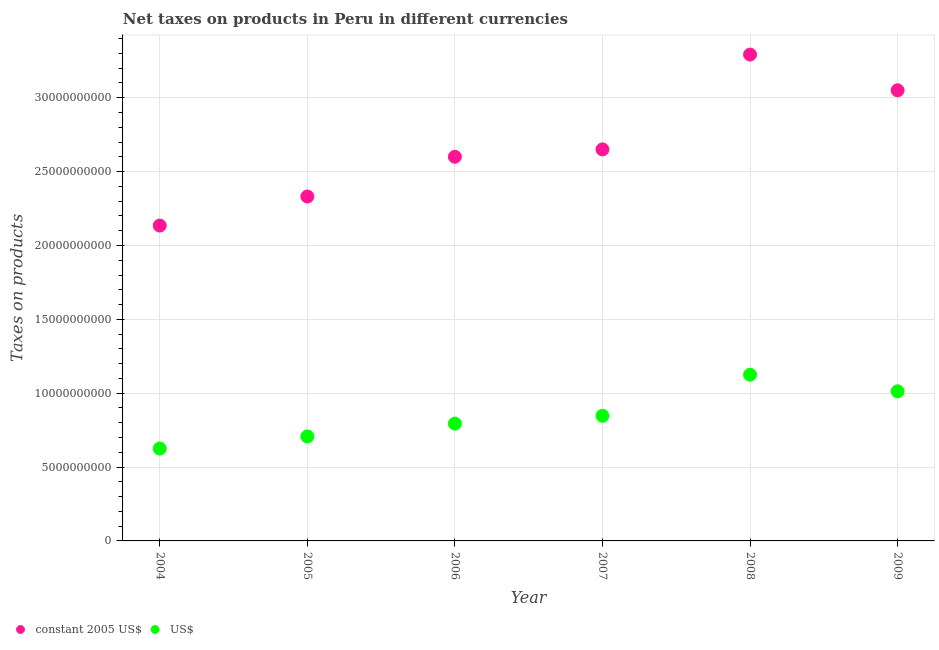How many different coloured dotlines are there?
Give a very brief answer. 2. Is the number of dotlines equal to the number of legend labels?
Keep it short and to the point. Yes. What is the net taxes in constant 2005 us$ in 2006?
Offer a very short reply. 2.60e+1. Across all years, what is the maximum net taxes in constant 2005 us$?
Your answer should be compact. 3.29e+1. Across all years, what is the minimum net taxes in us$?
Make the answer very short. 6.25e+09. In which year was the net taxes in constant 2005 us$ minimum?
Give a very brief answer. 2004. What is the total net taxes in us$ in the graph?
Make the answer very short. 5.11e+1. What is the difference between the net taxes in us$ in 2005 and that in 2007?
Your answer should be compact. -1.40e+09. What is the difference between the net taxes in us$ in 2004 and the net taxes in constant 2005 us$ in 2005?
Keep it short and to the point. -1.71e+1. What is the average net taxes in us$ per year?
Make the answer very short. 8.52e+09. In the year 2008, what is the difference between the net taxes in constant 2005 us$ and net taxes in us$?
Make the answer very short. 2.17e+1. What is the ratio of the net taxes in us$ in 2007 to that in 2009?
Provide a short and direct response. 0.84. Is the net taxes in us$ in 2008 less than that in 2009?
Provide a short and direct response. No. What is the difference between the highest and the second highest net taxes in constant 2005 us$?
Give a very brief answer. 2.42e+09. What is the difference between the highest and the lowest net taxes in constant 2005 us$?
Keep it short and to the point. 1.16e+1. Does the net taxes in us$ monotonically increase over the years?
Offer a very short reply. No. Is the net taxes in us$ strictly greater than the net taxes in constant 2005 us$ over the years?
Give a very brief answer. No. How many years are there in the graph?
Keep it short and to the point. 6. What is the difference between two consecutive major ticks on the Y-axis?
Offer a terse response. 5.00e+09. Are the values on the major ticks of Y-axis written in scientific E-notation?
Your answer should be very brief. No. How many legend labels are there?
Make the answer very short. 2. What is the title of the graph?
Your answer should be very brief. Net taxes on products in Peru in different currencies. Does "Frequency of shipment arrival" appear as one of the legend labels in the graph?
Make the answer very short. No. What is the label or title of the Y-axis?
Keep it short and to the point. Taxes on products. What is the Taxes on products of constant 2005 US$ in 2004?
Give a very brief answer. 2.13e+1. What is the Taxes on products in US$ in 2004?
Offer a terse response. 6.25e+09. What is the Taxes on products in constant 2005 US$ in 2005?
Ensure brevity in your answer.  2.33e+1. What is the Taxes on products in US$ in 2005?
Offer a very short reply. 7.07e+09. What is the Taxes on products in constant 2005 US$ in 2006?
Keep it short and to the point. 2.60e+1. What is the Taxes on products in US$ in 2006?
Your answer should be compact. 7.94e+09. What is the Taxes on products of constant 2005 US$ in 2007?
Keep it short and to the point. 2.65e+1. What is the Taxes on products in US$ in 2007?
Provide a succinct answer. 8.47e+09. What is the Taxes on products of constant 2005 US$ in 2008?
Keep it short and to the point. 3.29e+1. What is the Taxes on products of US$ in 2008?
Make the answer very short. 1.13e+1. What is the Taxes on products in constant 2005 US$ in 2009?
Your answer should be very brief. 3.05e+1. What is the Taxes on products of US$ in 2009?
Ensure brevity in your answer.  1.01e+1. Across all years, what is the maximum Taxes on products of constant 2005 US$?
Your answer should be very brief. 3.29e+1. Across all years, what is the maximum Taxes on products of US$?
Give a very brief answer. 1.13e+1. Across all years, what is the minimum Taxes on products of constant 2005 US$?
Keep it short and to the point. 2.13e+1. Across all years, what is the minimum Taxes on products of US$?
Provide a short and direct response. 6.25e+09. What is the total Taxes on products of constant 2005 US$ in the graph?
Provide a short and direct response. 1.61e+11. What is the total Taxes on products in US$ in the graph?
Your response must be concise. 5.11e+1. What is the difference between the Taxes on products in constant 2005 US$ in 2004 and that in 2005?
Provide a short and direct response. -1.97e+09. What is the difference between the Taxes on products of US$ in 2004 and that in 2005?
Provide a short and direct response. -8.19e+08. What is the difference between the Taxes on products of constant 2005 US$ in 2004 and that in 2006?
Give a very brief answer. -4.66e+09. What is the difference between the Taxes on products of US$ in 2004 and that in 2006?
Ensure brevity in your answer.  -1.69e+09. What is the difference between the Taxes on products of constant 2005 US$ in 2004 and that in 2007?
Your answer should be very brief. -5.16e+09. What is the difference between the Taxes on products of US$ in 2004 and that in 2007?
Keep it short and to the point. -2.22e+09. What is the difference between the Taxes on products of constant 2005 US$ in 2004 and that in 2008?
Your answer should be compact. -1.16e+1. What is the difference between the Taxes on products of US$ in 2004 and that in 2008?
Make the answer very short. -5.00e+09. What is the difference between the Taxes on products of constant 2005 US$ in 2004 and that in 2009?
Offer a terse response. -9.16e+09. What is the difference between the Taxes on products of US$ in 2004 and that in 2009?
Your answer should be compact. -3.87e+09. What is the difference between the Taxes on products in constant 2005 US$ in 2005 and that in 2006?
Make the answer very short. -2.69e+09. What is the difference between the Taxes on products of US$ in 2005 and that in 2006?
Ensure brevity in your answer.  -8.69e+08. What is the difference between the Taxes on products in constant 2005 US$ in 2005 and that in 2007?
Your answer should be compact. -3.19e+09. What is the difference between the Taxes on products in US$ in 2005 and that in 2007?
Your answer should be compact. -1.40e+09. What is the difference between the Taxes on products of constant 2005 US$ in 2005 and that in 2008?
Offer a very short reply. -9.61e+09. What is the difference between the Taxes on products in US$ in 2005 and that in 2008?
Provide a succinct answer. -4.18e+09. What is the difference between the Taxes on products of constant 2005 US$ in 2005 and that in 2009?
Provide a succinct answer. -7.19e+09. What is the difference between the Taxes on products in US$ in 2005 and that in 2009?
Offer a terse response. -3.05e+09. What is the difference between the Taxes on products in constant 2005 US$ in 2006 and that in 2007?
Keep it short and to the point. -4.99e+08. What is the difference between the Taxes on products of US$ in 2006 and that in 2007?
Give a very brief answer. -5.29e+08. What is the difference between the Taxes on products of constant 2005 US$ in 2006 and that in 2008?
Provide a succinct answer. -6.92e+09. What is the difference between the Taxes on products in US$ in 2006 and that in 2008?
Offer a terse response. -3.31e+09. What is the difference between the Taxes on products of constant 2005 US$ in 2006 and that in 2009?
Ensure brevity in your answer.  -4.50e+09. What is the difference between the Taxes on products of US$ in 2006 and that in 2009?
Your response must be concise. -2.19e+09. What is the difference between the Taxes on products of constant 2005 US$ in 2007 and that in 2008?
Your response must be concise. -6.42e+09. What is the difference between the Taxes on products of US$ in 2007 and that in 2008?
Provide a succinct answer. -2.78e+09. What is the difference between the Taxes on products of constant 2005 US$ in 2007 and that in 2009?
Give a very brief answer. -4.00e+09. What is the difference between the Taxes on products in US$ in 2007 and that in 2009?
Provide a short and direct response. -1.66e+09. What is the difference between the Taxes on products in constant 2005 US$ in 2008 and that in 2009?
Make the answer very short. 2.42e+09. What is the difference between the Taxes on products in US$ in 2008 and that in 2009?
Ensure brevity in your answer.  1.13e+09. What is the difference between the Taxes on products of constant 2005 US$ in 2004 and the Taxes on products of US$ in 2005?
Give a very brief answer. 1.43e+1. What is the difference between the Taxes on products in constant 2005 US$ in 2004 and the Taxes on products in US$ in 2006?
Offer a very short reply. 1.34e+1. What is the difference between the Taxes on products of constant 2005 US$ in 2004 and the Taxes on products of US$ in 2007?
Your response must be concise. 1.29e+1. What is the difference between the Taxes on products in constant 2005 US$ in 2004 and the Taxes on products in US$ in 2008?
Give a very brief answer. 1.01e+1. What is the difference between the Taxes on products in constant 2005 US$ in 2004 and the Taxes on products in US$ in 2009?
Your response must be concise. 1.12e+1. What is the difference between the Taxes on products of constant 2005 US$ in 2005 and the Taxes on products of US$ in 2006?
Offer a very short reply. 1.54e+1. What is the difference between the Taxes on products in constant 2005 US$ in 2005 and the Taxes on products in US$ in 2007?
Your response must be concise. 1.48e+1. What is the difference between the Taxes on products in constant 2005 US$ in 2005 and the Taxes on products in US$ in 2008?
Make the answer very short. 1.21e+1. What is the difference between the Taxes on products of constant 2005 US$ in 2005 and the Taxes on products of US$ in 2009?
Give a very brief answer. 1.32e+1. What is the difference between the Taxes on products in constant 2005 US$ in 2006 and the Taxes on products in US$ in 2007?
Your answer should be very brief. 1.75e+1. What is the difference between the Taxes on products in constant 2005 US$ in 2006 and the Taxes on products in US$ in 2008?
Make the answer very short. 1.48e+1. What is the difference between the Taxes on products of constant 2005 US$ in 2006 and the Taxes on products of US$ in 2009?
Ensure brevity in your answer.  1.59e+1. What is the difference between the Taxes on products of constant 2005 US$ in 2007 and the Taxes on products of US$ in 2008?
Make the answer very short. 1.53e+1. What is the difference between the Taxes on products of constant 2005 US$ in 2007 and the Taxes on products of US$ in 2009?
Your response must be concise. 1.64e+1. What is the difference between the Taxes on products of constant 2005 US$ in 2008 and the Taxes on products of US$ in 2009?
Your answer should be compact. 2.28e+1. What is the average Taxes on products of constant 2005 US$ per year?
Your answer should be very brief. 2.68e+1. What is the average Taxes on products of US$ per year?
Give a very brief answer. 8.52e+09. In the year 2004, what is the difference between the Taxes on products of constant 2005 US$ and Taxes on products of US$?
Offer a very short reply. 1.51e+1. In the year 2005, what is the difference between the Taxes on products in constant 2005 US$ and Taxes on products in US$?
Offer a very short reply. 1.62e+1. In the year 2006, what is the difference between the Taxes on products in constant 2005 US$ and Taxes on products in US$?
Your answer should be compact. 1.81e+1. In the year 2007, what is the difference between the Taxes on products of constant 2005 US$ and Taxes on products of US$?
Your answer should be very brief. 1.80e+1. In the year 2008, what is the difference between the Taxes on products in constant 2005 US$ and Taxes on products in US$?
Provide a succinct answer. 2.17e+1. In the year 2009, what is the difference between the Taxes on products in constant 2005 US$ and Taxes on products in US$?
Offer a terse response. 2.04e+1. What is the ratio of the Taxes on products in constant 2005 US$ in 2004 to that in 2005?
Provide a short and direct response. 0.92. What is the ratio of the Taxes on products of US$ in 2004 to that in 2005?
Make the answer very short. 0.88. What is the ratio of the Taxes on products of constant 2005 US$ in 2004 to that in 2006?
Your answer should be compact. 0.82. What is the ratio of the Taxes on products of US$ in 2004 to that in 2006?
Your answer should be compact. 0.79. What is the ratio of the Taxes on products in constant 2005 US$ in 2004 to that in 2007?
Keep it short and to the point. 0.81. What is the ratio of the Taxes on products of US$ in 2004 to that in 2007?
Make the answer very short. 0.74. What is the ratio of the Taxes on products in constant 2005 US$ in 2004 to that in 2008?
Make the answer very short. 0.65. What is the ratio of the Taxes on products of US$ in 2004 to that in 2008?
Ensure brevity in your answer.  0.56. What is the ratio of the Taxes on products in constant 2005 US$ in 2004 to that in 2009?
Offer a terse response. 0.7. What is the ratio of the Taxes on products of US$ in 2004 to that in 2009?
Ensure brevity in your answer.  0.62. What is the ratio of the Taxes on products of constant 2005 US$ in 2005 to that in 2006?
Keep it short and to the point. 0.9. What is the ratio of the Taxes on products of US$ in 2005 to that in 2006?
Provide a succinct answer. 0.89. What is the ratio of the Taxes on products of constant 2005 US$ in 2005 to that in 2007?
Keep it short and to the point. 0.88. What is the ratio of the Taxes on products in US$ in 2005 to that in 2007?
Your answer should be very brief. 0.83. What is the ratio of the Taxes on products in constant 2005 US$ in 2005 to that in 2008?
Provide a short and direct response. 0.71. What is the ratio of the Taxes on products in US$ in 2005 to that in 2008?
Your answer should be compact. 0.63. What is the ratio of the Taxes on products in constant 2005 US$ in 2005 to that in 2009?
Your answer should be compact. 0.76. What is the ratio of the Taxes on products in US$ in 2005 to that in 2009?
Keep it short and to the point. 0.7. What is the ratio of the Taxes on products of constant 2005 US$ in 2006 to that in 2007?
Provide a short and direct response. 0.98. What is the ratio of the Taxes on products of US$ in 2006 to that in 2007?
Provide a short and direct response. 0.94. What is the ratio of the Taxes on products in constant 2005 US$ in 2006 to that in 2008?
Your response must be concise. 0.79. What is the ratio of the Taxes on products of US$ in 2006 to that in 2008?
Give a very brief answer. 0.71. What is the ratio of the Taxes on products in constant 2005 US$ in 2006 to that in 2009?
Keep it short and to the point. 0.85. What is the ratio of the Taxes on products of US$ in 2006 to that in 2009?
Offer a very short reply. 0.78. What is the ratio of the Taxes on products of constant 2005 US$ in 2007 to that in 2008?
Your answer should be compact. 0.81. What is the ratio of the Taxes on products of US$ in 2007 to that in 2008?
Provide a succinct answer. 0.75. What is the ratio of the Taxes on products in constant 2005 US$ in 2007 to that in 2009?
Provide a succinct answer. 0.87. What is the ratio of the Taxes on products of US$ in 2007 to that in 2009?
Provide a succinct answer. 0.84. What is the ratio of the Taxes on products in constant 2005 US$ in 2008 to that in 2009?
Provide a short and direct response. 1.08. What is the ratio of the Taxes on products in US$ in 2008 to that in 2009?
Provide a succinct answer. 1.11. What is the difference between the highest and the second highest Taxes on products of constant 2005 US$?
Give a very brief answer. 2.42e+09. What is the difference between the highest and the second highest Taxes on products in US$?
Provide a succinct answer. 1.13e+09. What is the difference between the highest and the lowest Taxes on products in constant 2005 US$?
Give a very brief answer. 1.16e+1. What is the difference between the highest and the lowest Taxes on products in US$?
Provide a short and direct response. 5.00e+09. 